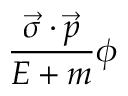<formula> <loc_0><loc_0><loc_500><loc_500>{ \frac { { \vec { \sigma } } \cdot { \vec { p } } } { E + m } } \phi</formula> 